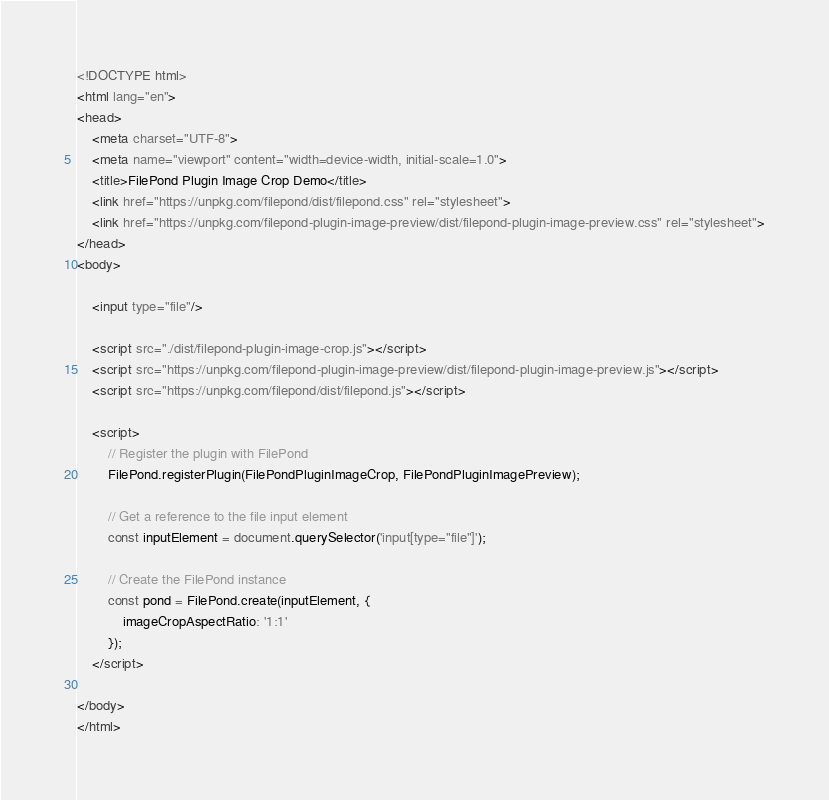Convert code to text. <code><loc_0><loc_0><loc_500><loc_500><_HTML_><!DOCTYPE html>
<html lang="en">
<head>
    <meta charset="UTF-8">
    <meta name="viewport" content="width=device-width, initial-scale=1.0">
    <title>FilePond Plugin Image Crop Demo</title>
    <link href="https://unpkg.com/filepond/dist/filepond.css" rel="stylesheet">
    <link href="https://unpkg.com/filepond-plugin-image-preview/dist/filepond-plugin-image-preview.css" rel="stylesheet">
</head>
<body>

    <input type="file"/>
    
    <script src="./dist/filepond-plugin-image-crop.js"></script>
    <script src="https://unpkg.com/filepond-plugin-image-preview/dist/filepond-plugin-image-preview.js"></script>
    <script src="https://unpkg.com/filepond/dist/filepond.js"></script>
    
    <script>
        // Register the plugin with FilePond
        FilePond.registerPlugin(FilePondPluginImageCrop, FilePondPluginImagePreview);

        // Get a reference to the file input element
        const inputElement = document.querySelector('input[type="file"]');

        // Create the FilePond instance
        const pond = FilePond.create(inputElement, {
            imageCropAspectRatio: '1:1'
        });
    </script>

</body>
</html></code> 